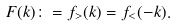<formula> <loc_0><loc_0><loc_500><loc_500>F ( k ) \colon = f _ { > } ( k ) = f _ { < } ( - k ) .</formula> 